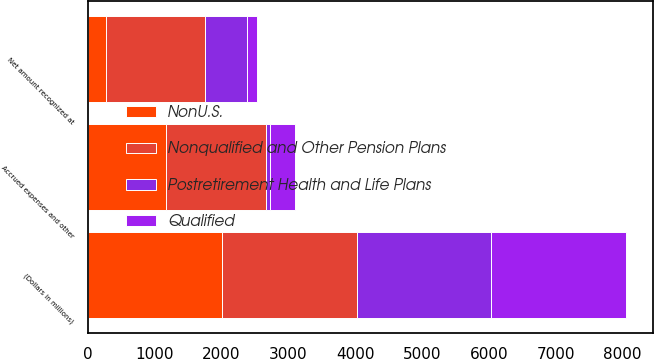<chart> <loc_0><loc_0><loc_500><loc_500><stacked_bar_chart><ecel><fcel>(Dollars in millions)<fcel>Accrued expenses and other<fcel>Net amount recognized at<nl><fcel>Postretirement Health and Life Plans<fcel>2012<fcel>57<fcel>619<nl><fcel>Qualified<fcel>2012<fcel>374<fcel>154<nl><fcel>NonU.S.<fcel>2012<fcel>1179<fcel>271<nl><fcel>Nonqualified and Other Pension Plans<fcel>2012<fcel>1488<fcel>1488<nl></chart> 